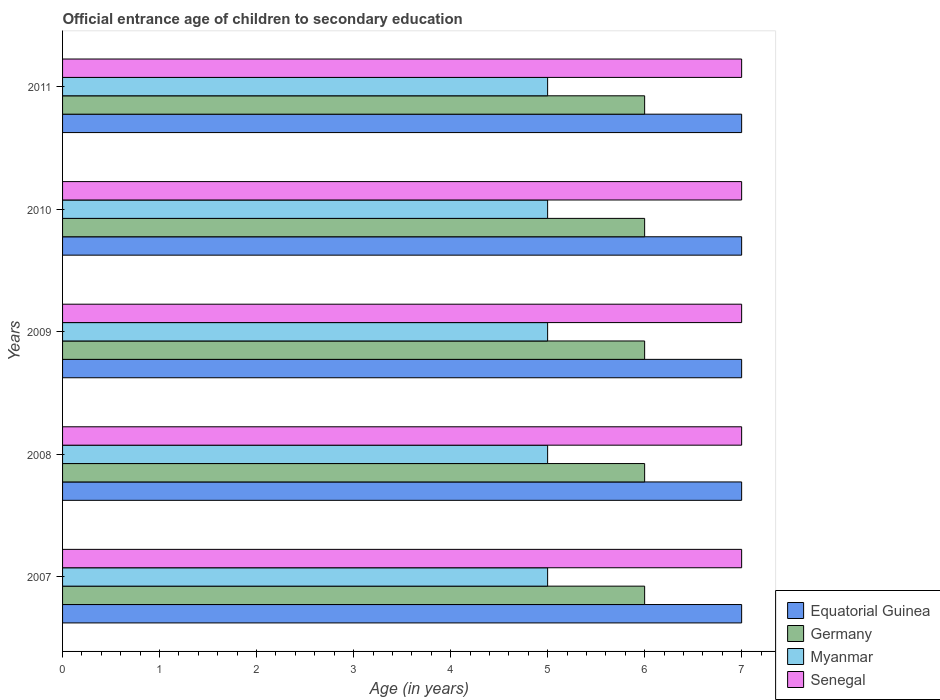Are the number of bars per tick equal to the number of legend labels?
Ensure brevity in your answer.  Yes. What is the label of the 3rd group of bars from the top?
Give a very brief answer. 2009. What is the secondary school starting age of children in Senegal in 2007?
Provide a short and direct response. 7. Across all years, what is the maximum secondary school starting age of children in Equatorial Guinea?
Offer a very short reply. 7. Across all years, what is the minimum secondary school starting age of children in Equatorial Guinea?
Provide a short and direct response. 7. What is the total secondary school starting age of children in Senegal in the graph?
Keep it short and to the point. 35. What is the difference between the secondary school starting age of children in Senegal in 2010 and the secondary school starting age of children in Myanmar in 2008?
Offer a very short reply. 2. In the year 2010, what is the difference between the secondary school starting age of children in Myanmar and secondary school starting age of children in Equatorial Guinea?
Your answer should be compact. -2. In how many years, is the secondary school starting age of children in Myanmar greater than 2.8 years?
Your answer should be compact. 5. Is the secondary school starting age of children in Senegal in 2007 less than that in 2009?
Your answer should be very brief. No. What is the difference between the highest and the second highest secondary school starting age of children in Germany?
Keep it short and to the point. 0. What is the difference between the highest and the lowest secondary school starting age of children in Senegal?
Ensure brevity in your answer.  0. What does the 2nd bar from the top in 2007 represents?
Ensure brevity in your answer.  Myanmar. What does the 2nd bar from the bottom in 2008 represents?
Provide a succinct answer. Germany. How many years are there in the graph?
Provide a succinct answer. 5. What is the difference between two consecutive major ticks on the X-axis?
Offer a terse response. 1. Are the values on the major ticks of X-axis written in scientific E-notation?
Your response must be concise. No. Does the graph contain any zero values?
Make the answer very short. No. What is the title of the graph?
Provide a succinct answer. Official entrance age of children to secondary education. Does "Barbados" appear as one of the legend labels in the graph?
Give a very brief answer. No. What is the label or title of the X-axis?
Keep it short and to the point. Age (in years). What is the label or title of the Y-axis?
Provide a short and direct response. Years. What is the Age (in years) in Germany in 2007?
Your answer should be compact. 6. What is the Age (in years) of Equatorial Guinea in 2008?
Ensure brevity in your answer.  7. What is the Age (in years) of Senegal in 2008?
Provide a short and direct response. 7. What is the Age (in years) of Germany in 2009?
Provide a succinct answer. 6. What is the Age (in years) in Senegal in 2011?
Give a very brief answer. 7. Across all years, what is the maximum Age (in years) in Equatorial Guinea?
Make the answer very short. 7. Across all years, what is the maximum Age (in years) in Germany?
Offer a very short reply. 6. Across all years, what is the minimum Age (in years) of Equatorial Guinea?
Offer a terse response. 7. Across all years, what is the minimum Age (in years) in Germany?
Ensure brevity in your answer.  6. Across all years, what is the minimum Age (in years) in Myanmar?
Give a very brief answer. 5. Across all years, what is the minimum Age (in years) in Senegal?
Keep it short and to the point. 7. What is the total Age (in years) of Equatorial Guinea in the graph?
Ensure brevity in your answer.  35. What is the total Age (in years) of Germany in the graph?
Keep it short and to the point. 30. What is the total Age (in years) of Myanmar in the graph?
Your response must be concise. 25. What is the total Age (in years) in Senegal in the graph?
Provide a short and direct response. 35. What is the difference between the Age (in years) of Equatorial Guinea in 2007 and that in 2008?
Give a very brief answer. 0. What is the difference between the Age (in years) of Germany in 2007 and that in 2008?
Your answer should be very brief. 0. What is the difference between the Age (in years) in Senegal in 2007 and that in 2008?
Make the answer very short. 0. What is the difference between the Age (in years) in Germany in 2007 and that in 2009?
Offer a terse response. 0. What is the difference between the Age (in years) of Equatorial Guinea in 2007 and that in 2010?
Keep it short and to the point. 0. What is the difference between the Age (in years) of Germany in 2007 and that in 2010?
Make the answer very short. 0. What is the difference between the Age (in years) of Senegal in 2007 and that in 2010?
Ensure brevity in your answer.  0. What is the difference between the Age (in years) in Germany in 2007 and that in 2011?
Ensure brevity in your answer.  0. What is the difference between the Age (in years) of Myanmar in 2007 and that in 2011?
Keep it short and to the point. 0. What is the difference between the Age (in years) of Senegal in 2007 and that in 2011?
Offer a terse response. 0. What is the difference between the Age (in years) in Germany in 2008 and that in 2009?
Your answer should be compact. 0. What is the difference between the Age (in years) of Senegal in 2008 and that in 2009?
Offer a very short reply. 0. What is the difference between the Age (in years) in Germany in 2008 and that in 2010?
Make the answer very short. 0. What is the difference between the Age (in years) of Myanmar in 2008 and that in 2010?
Give a very brief answer. 0. What is the difference between the Age (in years) of Equatorial Guinea in 2009 and that in 2010?
Your answer should be very brief. 0. What is the difference between the Age (in years) of Germany in 2009 and that in 2010?
Offer a very short reply. 0. What is the difference between the Age (in years) in Myanmar in 2009 and that in 2010?
Provide a succinct answer. 0. What is the difference between the Age (in years) in Senegal in 2009 and that in 2011?
Provide a succinct answer. 0. What is the difference between the Age (in years) in Equatorial Guinea in 2010 and that in 2011?
Ensure brevity in your answer.  0. What is the difference between the Age (in years) in Germany in 2010 and that in 2011?
Provide a short and direct response. 0. What is the difference between the Age (in years) of Myanmar in 2010 and that in 2011?
Keep it short and to the point. 0. What is the difference between the Age (in years) of Senegal in 2010 and that in 2011?
Offer a very short reply. 0. What is the difference between the Age (in years) in Equatorial Guinea in 2007 and the Age (in years) in Germany in 2008?
Make the answer very short. 1. What is the difference between the Age (in years) in Equatorial Guinea in 2007 and the Age (in years) in Myanmar in 2008?
Keep it short and to the point. 2. What is the difference between the Age (in years) of Germany in 2007 and the Age (in years) of Senegal in 2008?
Your response must be concise. -1. What is the difference between the Age (in years) in Myanmar in 2007 and the Age (in years) in Senegal in 2008?
Provide a short and direct response. -2. What is the difference between the Age (in years) of Equatorial Guinea in 2007 and the Age (in years) of Myanmar in 2009?
Provide a short and direct response. 2. What is the difference between the Age (in years) in Equatorial Guinea in 2007 and the Age (in years) in Senegal in 2009?
Keep it short and to the point. 0. What is the difference between the Age (in years) in Germany in 2007 and the Age (in years) in Senegal in 2009?
Offer a terse response. -1. What is the difference between the Age (in years) of Myanmar in 2007 and the Age (in years) of Senegal in 2009?
Keep it short and to the point. -2. What is the difference between the Age (in years) in Equatorial Guinea in 2007 and the Age (in years) in Germany in 2010?
Your answer should be very brief. 1. What is the difference between the Age (in years) in Equatorial Guinea in 2007 and the Age (in years) in Senegal in 2010?
Your answer should be compact. 0. What is the difference between the Age (in years) of Myanmar in 2007 and the Age (in years) of Senegal in 2010?
Provide a succinct answer. -2. What is the difference between the Age (in years) in Equatorial Guinea in 2007 and the Age (in years) in Myanmar in 2011?
Provide a succinct answer. 2. What is the difference between the Age (in years) of Germany in 2007 and the Age (in years) of Senegal in 2011?
Your response must be concise. -1. What is the difference between the Age (in years) in Myanmar in 2007 and the Age (in years) in Senegal in 2011?
Offer a terse response. -2. What is the difference between the Age (in years) in Equatorial Guinea in 2008 and the Age (in years) in Germany in 2009?
Give a very brief answer. 1. What is the difference between the Age (in years) in Equatorial Guinea in 2008 and the Age (in years) in Senegal in 2009?
Offer a terse response. 0. What is the difference between the Age (in years) of Germany in 2008 and the Age (in years) of Senegal in 2009?
Your answer should be very brief. -1. What is the difference between the Age (in years) of Germany in 2008 and the Age (in years) of Myanmar in 2011?
Your response must be concise. 1. What is the difference between the Age (in years) in Germany in 2008 and the Age (in years) in Senegal in 2011?
Provide a short and direct response. -1. What is the difference between the Age (in years) in Myanmar in 2008 and the Age (in years) in Senegal in 2011?
Give a very brief answer. -2. What is the difference between the Age (in years) in Equatorial Guinea in 2009 and the Age (in years) in Myanmar in 2010?
Offer a terse response. 2. What is the difference between the Age (in years) in Equatorial Guinea in 2009 and the Age (in years) in Senegal in 2010?
Offer a terse response. 0. What is the difference between the Age (in years) in Germany in 2009 and the Age (in years) in Myanmar in 2010?
Give a very brief answer. 1. What is the difference between the Age (in years) in Germany in 2009 and the Age (in years) in Senegal in 2010?
Keep it short and to the point. -1. What is the difference between the Age (in years) of Myanmar in 2009 and the Age (in years) of Senegal in 2010?
Keep it short and to the point. -2. What is the difference between the Age (in years) of Equatorial Guinea in 2009 and the Age (in years) of Germany in 2011?
Offer a terse response. 1. What is the difference between the Age (in years) of Equatorial Guinea in 2009 and the Age (in years) of Myanmar in 2011?
Make the answer very short. 2. What is the difference between the Age (in years) of Equatorial Guinea in 2009 and the Age (in years) of Senegal in 2011?
Your response must be concise. 0. What is the difference between the Age (in years) of Germany in 2009 and the Age (in years) of Myanmar in 2011?
Offer a very short reply. 1. What is the difference between the Age (in years) of Germany in 2009 and the Age (in years) of Senegal in 2011?
Make the answer very short. -1. What is the difference between the Age (in years) of Myanmar in 2009 and the Age (in years) of Senegal in 2011?
Provide a succinct answer. -2. What is the difference between the Age (in years) in Germany in 2010 and the Age (in years) in Myanmar in 2011?
Offer a terse response. 1. What is the difference between the Age (in years) in Germany in 2010 and the Age (in years) in Senegal in 2011?
Keep it short and to the point. -1. What is the average Age (in years) of Germany per year?
Ensure brevity in your answer.  6. What is the average Age (in years) of Myanmar per year?
Your answer should be compact. 5. In the year 2007, what is the difference between the Age (in years) of Equatorial Guinea and Age (in years) of Myanmar?
Your response must be concise. 2. In the year 2007, what is the difference between the Age (in years) of Myanmar and Age (in years) of Senegal?
Ensure brevity in your answer.  -2. In the year 2008, what is the difference between the Age (in years) of Equatorial Guinea and Age (in years) of Germany?
Your response must be concise. 1. In the year 2008, what is the difference between the Age (in years) of Germany and Age (in years) of Myanmar?
Make the answer very short. 1. In the year 2009, what is the difference between the Age (in years) of Equatorial Guinea and Age (in years) of Germany?
Ensure brevity in your answer.  1. In the year 2009, what is the difference between the Age (in years) in Equatorial Guinea and Age (in years) in Myanmar?
Make the answer very short. 2. In the year 2009, what is the difference between the Age (in years) of Equatorial Guinea and Age (in years) of Senegal?
Provide a succinct answer. 0. In the year 2009, what is the difference between the Age (in years) of Germany and Age (in years) of Myanmar?
Provide a succinct answer. 1. In the year 2009, what is the difference between the Age (in years) of Germany and Age (in years) of Senegal?
Your answer should be compact. -1. In the year 2009, what is the difference between the Age (in years) in Myanmar and Age (in years) in Senegal?
Ensure brevity in your answer.  -2. In the year 2010, what is the difference between the Age (in years) in Equatorial Guinea and Age (in years) in Myanmar?
Give a very brief answer. 2. In the year 2010, what is the difference between the Age (in years) of Germany and Age (in years) of Myanmar?
Your answer should be compact. 1. In the year 2010, what is the difference between the Age (in years) of Myanmar and Age (in years) of Senegal?
Your answer should be very brief. -2. In the year 2011, what is the difference between the Age (in years) in Equatorial Guinea and Age (in years) in Germany?
Offer a terse response. 1. In the year 2011, what is the difference between the Age (in years) in Equatorial Guinea and Age (in years) in Senegal?
Provide a succinct answer. 0. In the year 2011, what is the difference between the Age (in years) of Myanmar and Age (in years) of Senegal?
Your answer should be compact. -2. What is the ratio of the Age (in years) of Equatorial Guinea in 2007 to that in 2008?
Ensure brevity in your answer.  1. What is the ratio of the Age (in years) of Senegal in 2007 to that in 2008?
Give a very brief answer. 1. What is the ratio of the Age (in years) of Equatorial Guinea in 2007 to that in 2009?
Offer a very short reply. 1. What is the ratio of the Age (in years) in Germany in 2007 to that in 2009?
Give a very brief answer. 1. What is the ratio of the Age (in years) of Equatorial Guinea in 2007 to that in 2011?
Your answer should be very brief. 1. What is the ratio of the Age (in years) of Germany in 2007 to that in 2011?
Offer a very short reply. 1. What is the ratio of the Age (in years) in Senegal in 2007 to that in 2011?
Provide a short and direct response. 1. What is the ratio of the Age (in years) in Equatorial Guinea in 2008 to that in 2009?
Your answer should be very brief. 1. What is the ratio of the Age (in years) of Germany in 2008 to that in 2009?
Give a very brief answer. 1. What is the ratio of the Age (in years) in Senegal in 2008 to that in 2009?
Ensure brevity in your answer.  1. What is the ratio of the Age (in years) in Germany in 2008 to that in 2011?
Keep it short and to the point. 1. What is the ratio of the Age (in years) in Myanmar in 2008 to that in 2011?
Ensure brevity in your answer.  1. What is the ratio of the Age (in years) of Senegal in 2008 to that in 2011?
Your response must be concise. 1. What is the ratio of the Age (in years) of Equatorial Guinea in 2009 to that in 2010?
Your answer should be compact. 1. What is the ratio of the Age (in years) of Germany in 2009 to that in 2010?
Offer a very short reply. 1. What is the ratio of the Age (in years) in Senegal in 2009 to that in 2010?
Your answer should be compact. 1. What is the ratio of the Age (in years) of Equatorial Guinea in 2009 to that in 2011?
Keep it short and to the point. 1. What is the ratio of the Age (in years) in Senegal in 2009 to that in 2011?
Your answer should be compact. 1. What is the difference between the highest and the second highest Age (in years) of Equatorial Guinea?
Keep it short and to the point. 0. What is the difference between the highest and the second highest Age (in years) in Germany?
Give a very brief answer. 0. What is the difference between the highest and the second highest Age (in years) in Myanmar?
Make the answer very short. 0. What is the difference between the highest and the second highest Age (in years) of Senegal?
Your answer should be compact. 0. What is the difference between the highest and the lowest Age (in years) in Equatorial Guinea?
Your answer should be very brief. 0. What is the difference between the highest and the lowest Age (in years) in Senegal?
Your response must be concise. 0. 